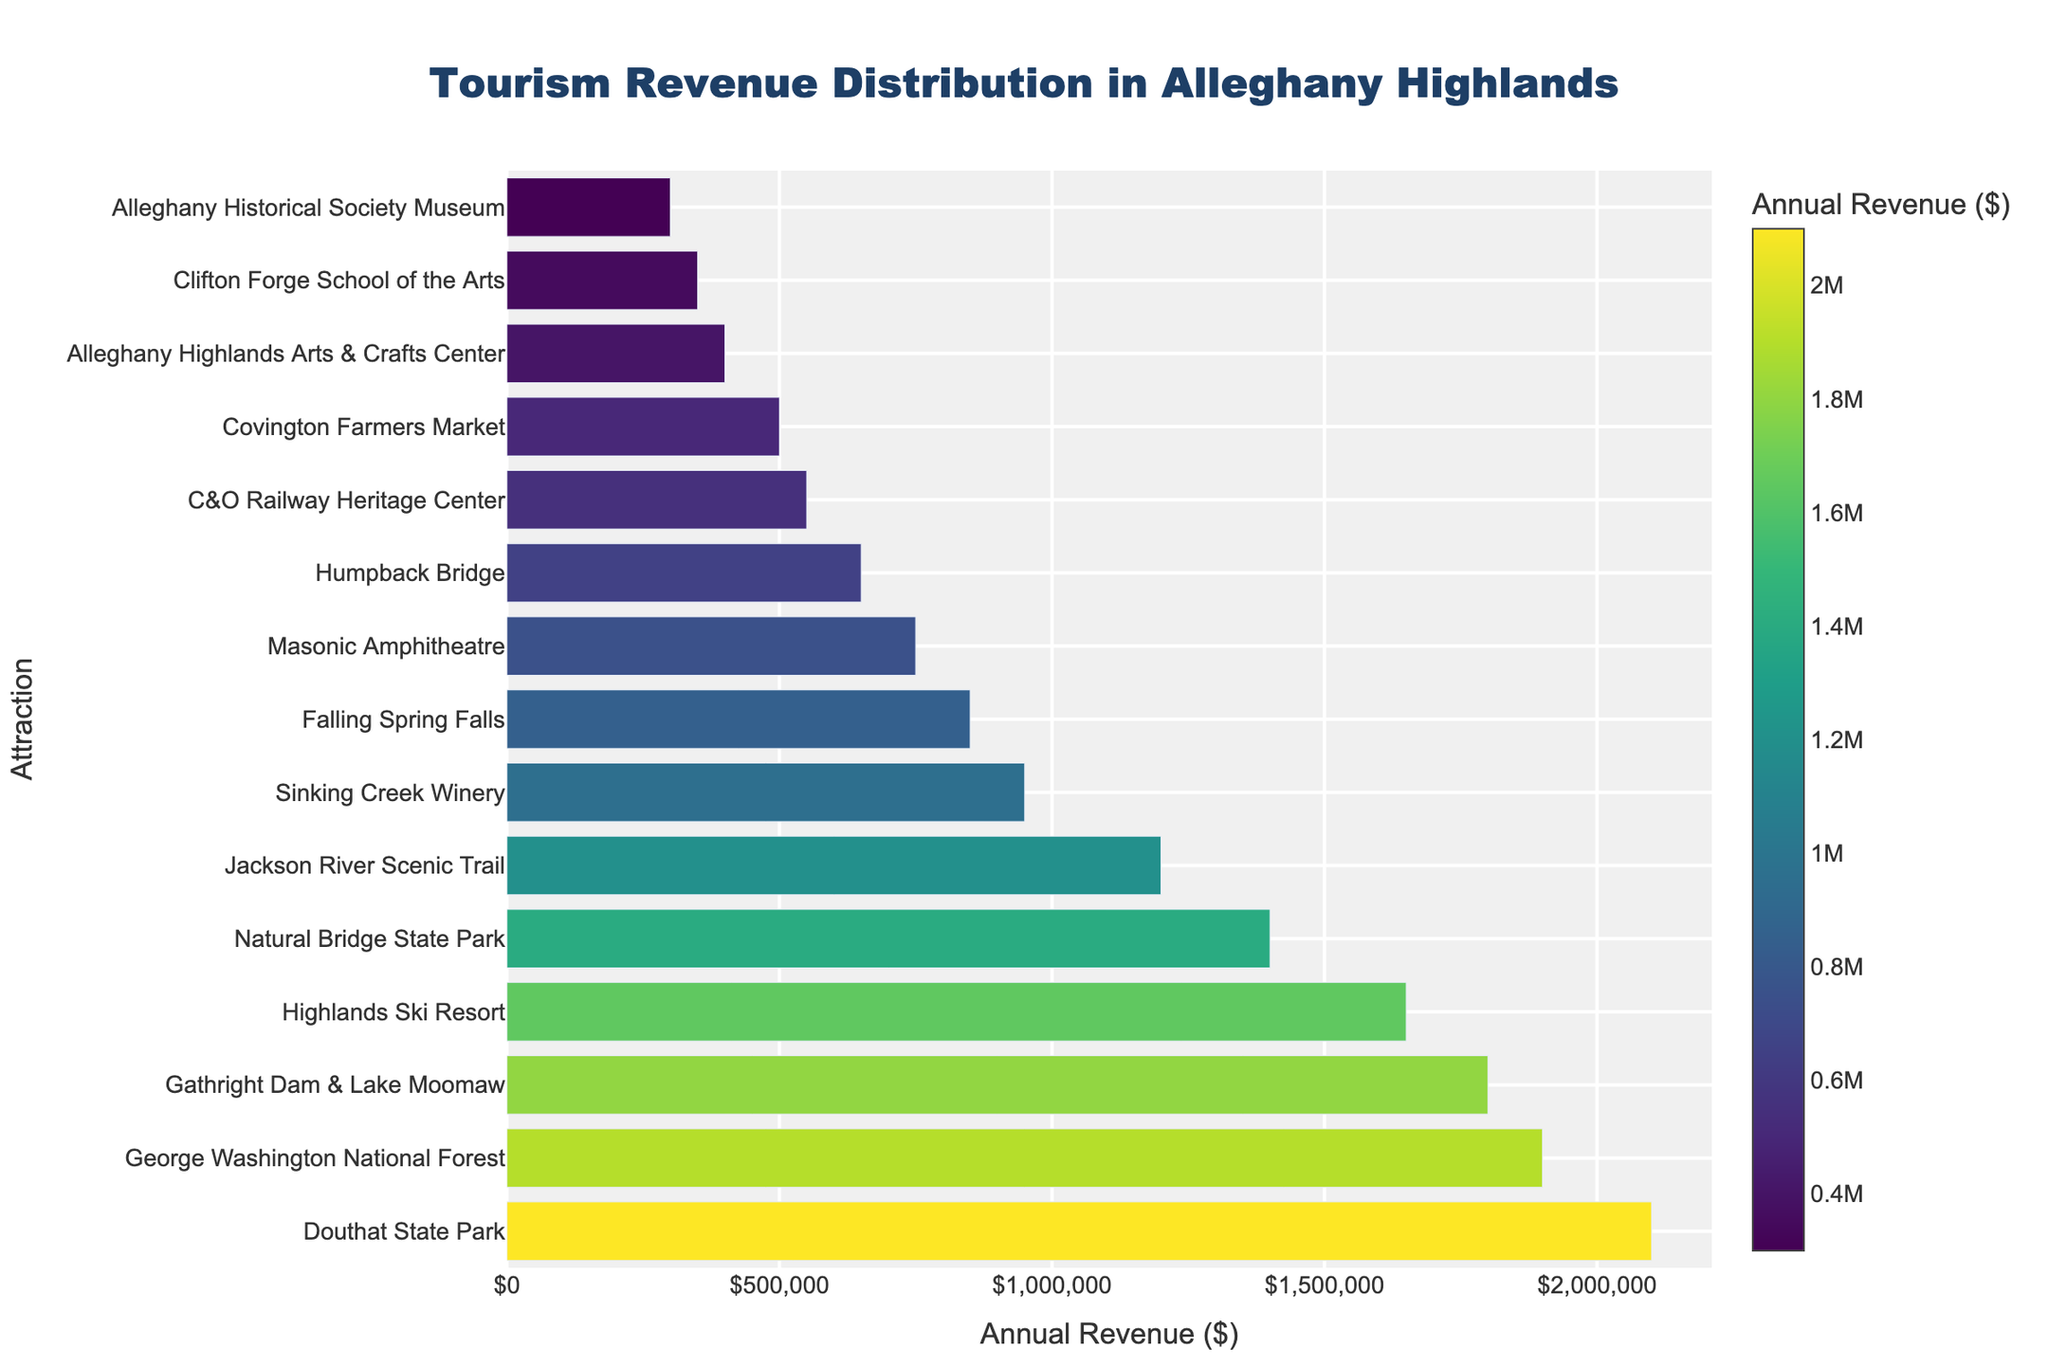Which attraction generates the highest annual revenue? To find out which attraction generates the highest revenue, look for the bar with the highest value on the horizontal axis. The figure shows that “Douthat State Park” has the highest bar.
Answer: Douthat State Park Which two attractions have the closest annual revenue? Identify bars that are visually closest in length. The “Masonic Amphitheatre” and “Falling Spring Falls” have annual revenues that are near each other, as their bars are similar in length.
Answer: Masonic Amphitheatre and Falling Spring Falls What's the combined annual revenue of the three attractions with the lowest revenue? Identify the three bars with the smallest lengths: “Clifton Forge School of the Arts,” “Alleghany Historical Society Museum,” and “Alleghany Highlands Arts & Crafts Center”. Add their annual revenues: 350,000 + 300,000 + 400,000 = 1,050,000
Answer: $1,050,000 How much more annual revenue does the George Washington National Forest generate compared to the C&O Railway Heritage Center? Look at the revenues for "George Washington National Forest" and "C&O Railway Heritage Center." Subtract the smaller value from the larger one: 1,900,000 - 550,000 = 1,350,000
Answer: $1,350,000 Which attraction has greater revenue, Jackson River Scenic Trail or Sinking Creek Winery? Compare the lengths of the bars for "Jackson River Scenic Trail" and "Sinking Creek Winery." "Jackson River Scenic Trail" has a longer bar, indicating higher revenue.
Answer: Jackson River Scenic Trail How many attractions generate an annual revenue of over $1,500,000? Count the number of bars exceeding the $1,500,000 mark on the horizontal axis. The attractions are “Douthat State Park,” “Gathright Dam & Lake Moomaw,” “Highlands Ski Resort,” and “George Washington National Forest.” This totals to 4 attractions.
Answer: 4 What is the average annual revenue of all attractions? Sum up the revenues of all attractions, then divide by the number of attractions. The calculation is: \( = \frac{2,100,000 + 850,000 + 650,000 + 1,200,000 + 1,800,000 + 550,000 + 400,000 + 350,000 + 750,000 + 300,000 + 950,000 + 1,650,000 + 1,400,000 + 500,000 + 1,900,000}{15} = \$1,026,666.67 \)
Answer: $1,026,666.67 What is the annual revenue for Natural Bridge State Park? Locate the bar labeled “Natural Bridge State Park” and note its value on the horizontal axis. The revenue is shown to be $1,400,000.
Answer: $1,400,000 Which attraction generates more revenue, Covington Farmers Market or Clifton Forge School of the Arts? Compare the lengths of the bars for "Covington Farmers Market" and "Clifton Forge School of the Arts." "Covington Farmers Market" has a longer bar.
Answer: Covington Farmers Market 